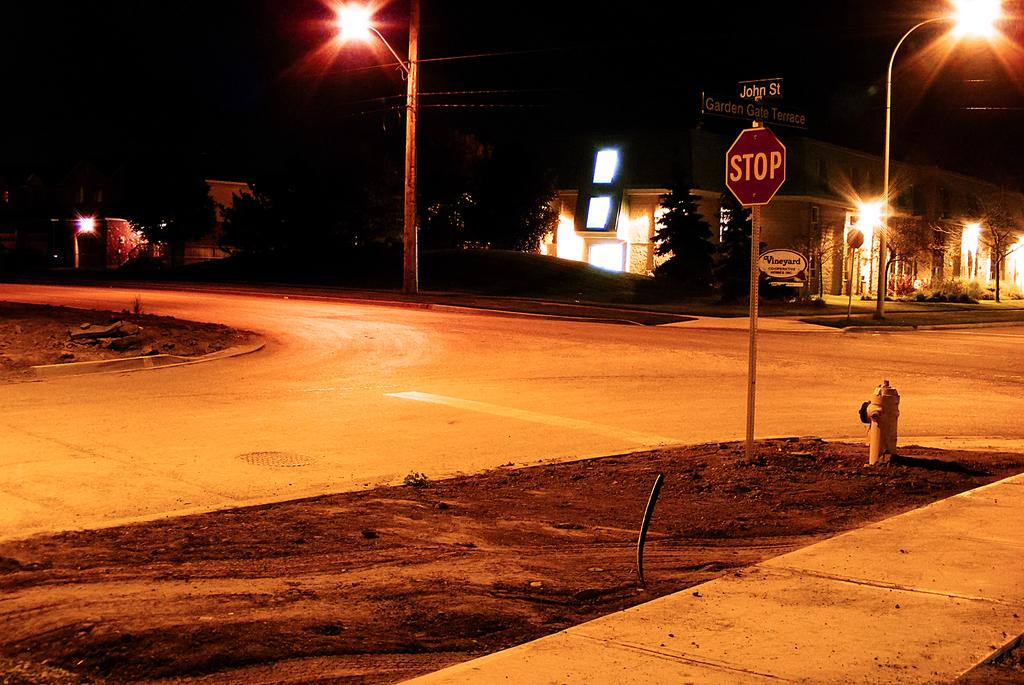What time of day is depicted in the image? The image was taken during nighttime. What is the main feature in the middle of the image? There is a road in the middle of the image. What structures are present to provide illumination in the image? Street light poles are present in the image. What type of signage is visible in the image? There is a signboard in the image. What safety equipment is visible in the image? A fire extinguisher is visible in the image. What types of structures are visible in the image? Buildings and trees are visible in the image. What type of coil is used to power the street lights in the image? There is no information about the type of coil used to power the street lights in the image. 